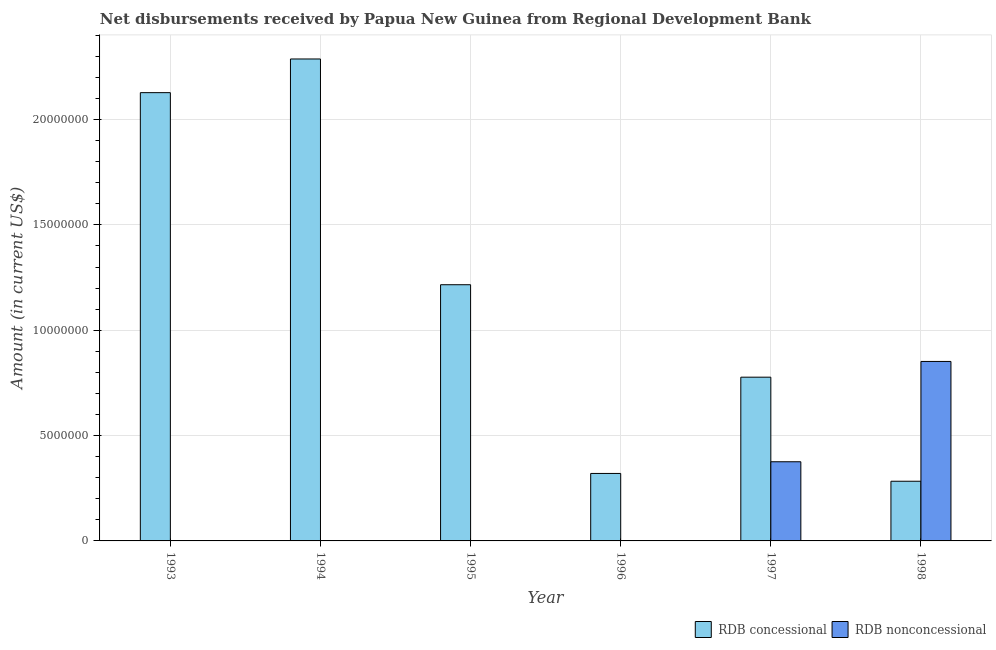Are the number of bars per tick equal to the number of legend labels?
Ensure brevity in your answer.  No. Are the number of bars on each tick of the X-axis equal?
Your response must be concise. No. How many bars are there on the 1st tick from the right?
Your response must be concise. 2. In how many cases, is the number of bars for a given year not equal to the number of legend labels?
Ensure brevity in your answer.  4. What is the net non concessional disbursements from rdb in 1993?
Ensure brevity in your answer.  0. Across all years, what is the maximum net concessional disbursements from rdb?
Make the answer very short. 2.29e+07. Across all years, what is the minimum net concessional disbursements from rdb?
Your answer should be very brief. 2.83e+06. In which year was the net non concessional disbursements from rdb maximum?
Your answer should be very brief. 1998. What is the total net concessional disbursements from rdb in the graph?
Make the answer very short. 7.01e+07. What is the difference between the net concessional disbursements from rdb in 1993 and that in 1994?
Keep it short and to the point. -1.60e+06. What is the difference between the net concessional disbursements from rdb in 1995 and the net non concessional disbursements from rdb in 1993?
Your response must be concise. -9.12e+06. What is the average net non concessional disbursements from rdb per year?
Ensure brevity in your answer.  2.05e+06. In the year 1995, what is the difference between the net concessional disbursements from rdb and net non concessional disbursements from rdb?
Make the answer very short. 0. What is the ratio of the net concessional disbursements from rdb in 1996 to that in 1997?
Keep it short and to the point. 0.41. Is the net concessional disbursements from rdb in 1994 less than that in 1995?
Provide a succinct answer. No. What is the difference between the highest and the second highest net concessional disbursements from rdb?
Offer a very short reply. 1.60e+06. What is the difference between the highest and the lowest net non concessional disbursements from rdb?
Make the answer very short. 8.52e+06. In how many years, is the net concessional disbursements from rdb greater than the average net concessional disbursements from rdb taken over all years?
Make the answer very short. 3. Is the sum of the net concessional disbursements from rdb in 1994 and 1995 greater than the maximum net non concessional disbursements from rdb across all years?
Your answer should be very brief. Yes. How many bars are there?
Make the answer very short. 8. How many years are there in the graph?
Your response must be concise. 6. Where does the legend appear in the graph?
Your answer should be compact. Bottom right. How many legend labels are there?
Your answer should be very brief. 2. What is the title of the graph?
Ensure brevity in your answer.  Net disbursements received by Papua New Guinea from Regional Development Bank. What is the label or title of the Y-axis?
Your response must be concise. Amount (in current US$). What is the Amount (in current US$) in RDB concessional in 1993?
Provide a short and direct response. 2.13e+07. What is the Amount (in current US$) of RDB nonconcessional in 1993?
Make the answer very short. 0. What is the Amount (in current US$) of RDB concessional in 1994?
Your answer should be compact. 2.29e+07. What is the Amount (in current US$) of RDB concessional in 1995?
Give a very brief answer. 1.22e+07. What is the Amount (in current US$) in RDB nonconcessional in 1995?
Offer a terse response. 0. What is the Amount (in current US$) in RDB concessional in 1996?
Provide a succinct answer. 3.20e+06. What is the Amount (in current US$) of RDB concessional in 1997?
Your answer should be very brief. 7.77e+06. What is the Amount (in current US$) of RDB nonconcessional in 1997?
Offer a terse response. 3.76e+06. What is the Amount (in current US$) in RDB concessional in 1998?
Offer a terse response. 2.83e+06. What is the Amount (in current US$) in RDB nonconcessional in 1998?
Keep it short and to the point. 8.52e+06. Across all years, what is the maximum Amount (in current US$) in RDB concessional?
Your response must be concise. 2.29e+07. Across all years, what is the maximum Amount (in current US$) of RDB nonconcessional?
Your answer should be very brief. 8.52e+06. Across all years, what is the minimum Amount (in current US$) of RDB concessional?
Ensure brevity in your answer.  2.83e+06. Across all years, what is the minimum Amount (in current US$) in RDB nonconcessional?
Your answer should be very brief. 0. What is the total Amount (in current US$) in RDB concessional in the graph?
Keep it short and to the point. 7.01e+07. What is the total Amount (in current US$) of RDB nonconcessional in the graph?
Your answer should be compact. 1.23e+07. What is the difference between the Amount (in current US$) of RDB concessional in 1993 and that in 1994?
Give a very brief answer. -1.60e+06. What is the difference between the Amount (in current US$) of RDB concessional in 1993 and that in 1995?
Make the answer very short. 9.12e+06. What is the difference between the Amount (in current US$) in RDB concessional in 1993 and that in 1996?
Your answer should be compact. 1.81e+07. What is the difference between the Amount (in current US$) in RDB concessional in 1993 and that in 1997?
Your answer should be very brief. 1.35e+07. What is the difference between the Amount (in current US$) in RDB concessional in 1993 and that in 1998?
Offer a very short reply. 1.84e+07. What is the difference between the Amount (in current US$) of RDB concessional in 1994 and that in 1995?
Make the answer very short. 1.07e+07. What is the difference between the Amount (in current US$) of RDB concessional in 1994 and that in 1996?
Your answer should be compact. 1.97e+07. What is the difference between the Amount (in current US$) of RDB concessional in 1994 and that in 1997?
Your answer should be compact. 1.51e+07. What is the difference between the Amount (in current US$) in RDB concessional in 1994 and that in 1998?
Offer a very short reply. 2.00e+07. What is the difference between the Amount (in current US$) of RDB concessional in 1995 and that in 1996?
Provide a succinct answer. 8.96e+06. What is the difference between the Amount (in current US$) of RDB concessional in 1995 and that in 1997?
Make the answer very short. 4.39e+06. What is the difference between the Amount (in current US$) in RDB concessional in 1995 and that in 1998?
Offer a very short reply. 9.33e+06. What is the difference between the Amount (in current US$) of RDB concessional in 1996 and that in 1997?
Your answer should be very brief. -4.57e+06. What is the difference between the Amount (in current US$) in RDB concessional in 1996 and that in 1998?
Your response must be concise. 3.70e+05. What is the difference between the Amount (in current US$) of RDB concessional in 1997 and that in 1998?
Your answer should be very brief. 4.94e+06. What is the difference between the Amount (in current US$) of RDB nonconcessional in 1997 and that in 1998?
Your response must be concise. -4.76e+06. What is the difference between the Amount (in current US$) in RDB concessional in 1993 and the Amount (in current US$) in RDB nonconcessional in 1997?
Keep it short and to the point. 1.75e+07. What is the difference between the Amount (in current US$) of RDB concessional in 1993 and the Amount (in current US$) of RDB nonconcessional in 1998?
Make the answer very short. 1.28e+07. What is the difference between the Amount (in current US$) in RDB concessional in 1994 and the Amount (in current US$) in RDB nonconcessional in 1997?
Keep it short and to the point. 1.91e+07. What is the difference between the Amount (in current US$) of RDB concessional in 1994 and the Amount (in current US$) of RDB nonconcessional in 1998?
Provide a succinct answer. 1.44e+07. What is the difference between the Amount (in current US$) of RDB concessional in 1995 and the Amount (in current US$) of RDB nonconcessional in 1997?
Give a very brief answer. 8.40e+06. What is the difference between the Amount (in current US$) of RDB concessional in 1995 and the Amount (in current US$) of RDB nonconcessional in 1998?
Offer a very short reply. 3.64e+06. What is the difference between the Amount (in current US$) of RDB concessional in 1996 and the Amount (in current US$) of RDB nonconcessional in 1997?
Keep it short and to the point. -5.55e+05. What is the difference between the Amount (in current US$) of RDB concessional in 1996 and the Amount (in current US$) of RDB nonconcessional in 1998?
Your response must be concise. -5.32e+06. What is the difference between the Amount (in current US$) of RDB concessional in 1997 and the Amount (in current US$) of RDB nonconcessional in 1998?
Provide a short and direct response. -7.47e+05. What is the average Amount (in current US$) of RDB concessional per year?
Keep it short and to the point. 1.17e+07. What is the average Amount (in current US$) of RDB nonconcessional per year?
Keep it short and to the point. 2.05e+06. In the year 1997, what is the difference between the Amount (in current US$) in RDB concessional and Amount (in current US$) in RDB nonconcessional?
Your answer should be very brief. 4.01e+06. In the year 1998, what is the difference between the Amount (in current US$) of RDB concessional and Amount (in current US$) of RDB nonconcessional?
Your answer should be compact. -5.69e+06. What is the ratio of the Amount (in current US$) in RDB concessional in 1993 to that in 1994?
Give a very brief answer. 0.93. What is the ratio of the Amount (in current US$) of RDB concessional in 1993 to that in 1995?
Your response must be concise. 1.75. What is the ratio of the Amount (in current US$) of RDB concessional in 1993 to that in 1996?
Provide a succinct answer. 6.64. What is the ratio of the Amount (in current US$) of RDB concessional in 1993 to that in 1997?
Your answer should be compact. 2.74. What is the ratio of the Amount (in current US$) of RDB concessional in 1993 to that in 1998?
Offer a very short reply. 7.51. What is the ratio of the Amount (in current US$) in RDB concessional in 1994 to that in 1995?
Your answer should be compact. 1.88. What is the ratio of the Amount (in current US$) of RDB concessional in 1994 to that in 1996?
Offer a terse response. 7.14. What is the ratio of the Amount (in current US$) of RDB concessional in 1994 to that in 1997?
Provide a short and direct response. 2.94. What is the ratio of the Amount (in current US$) in RDB concessional in 1994 to that in 1998?
Keep it short and to the point. 8.08. What is the ratio of the Amount (in current US$) of RDB concessional in 1995 to that in 1996?
Provide a short and direct response. 3.8. What is the ratio of the Amount (in current US$) of RDB concessional in 1995 to that in 1997?
Provide a short and direct response. 1.56. What is the ratio of the Amount (in current US$) in RDB concessional in 1995 to that in 1998?
Your answer should be very brief. 4.29. What is the ratio of the Amount (in current US$) in RDB concessional in 1996 to that in 1997?
Provide a succinct answer. 0.41. What is the ratio of the Amount (in current US$) of RDB concessional in 1996 to that in 1998?
Give a very brief answer. 1.13. What is the ratio of the Amount (in current US$) of RDB concessional in 1997 to that in 1998?
Make the answer very short. 2.74. What is the ratio of the Amount (in current US$) of RDB nonconcessional in 1997 to that in 1998?
Provide a succinct answer. 0.44. What is the difference between the highest and the second highest Amount (in current US$) in RDB concessional?
Your response must be concise. 1.60e+06. What is the difference between the highest and the lowest Amount (in current US$) in RDB concessional?
Make the answer very short. 2.00e+07. What is the difference between the highest and the lowest Amount (in current US$) in RDB nonconcessional?
Offer a very short reply. 8.52e+06. 